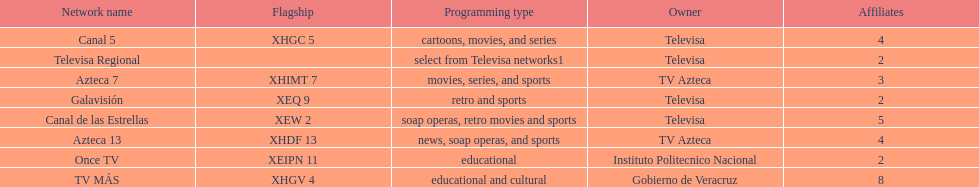How many networks show soap operas? 2. Parse the table in full. {'header': ['Network name', 'Flagship', 'Programming type', 'Owner', 'Affiliates'], 'rows': [['Canal 5', 'XHGC 5', 'cartoons, movies, and series', 'Televisa', '4'], ['Televisa Regional', '', 'select from Televisa networks1', 'Televisa', '2'], ['Azteca 7', 'XHIMT 7', 'movies, series, and sports', 'TV Azteca', '3'], ['Galavisión', 'XEQ 9', 'retro and sports', 'Televisa', '2'], ['Canal de las Estrellas', 'XEW 2', 'soap operas, retro movies and sports', 'Televisa', '5'], ['Azteca 13', 'XHDF 13', 'news, soap operas, and sports', 'TV Azteca', '4'], ['Once TV', 'XEIPN 11', 'educational', 'Instituto Politecnico Nacional', '2'], ['TV MÁS', 'XHGV 4', 'educational and cultural', 'Gobierno de Veracruz', '8']]} 